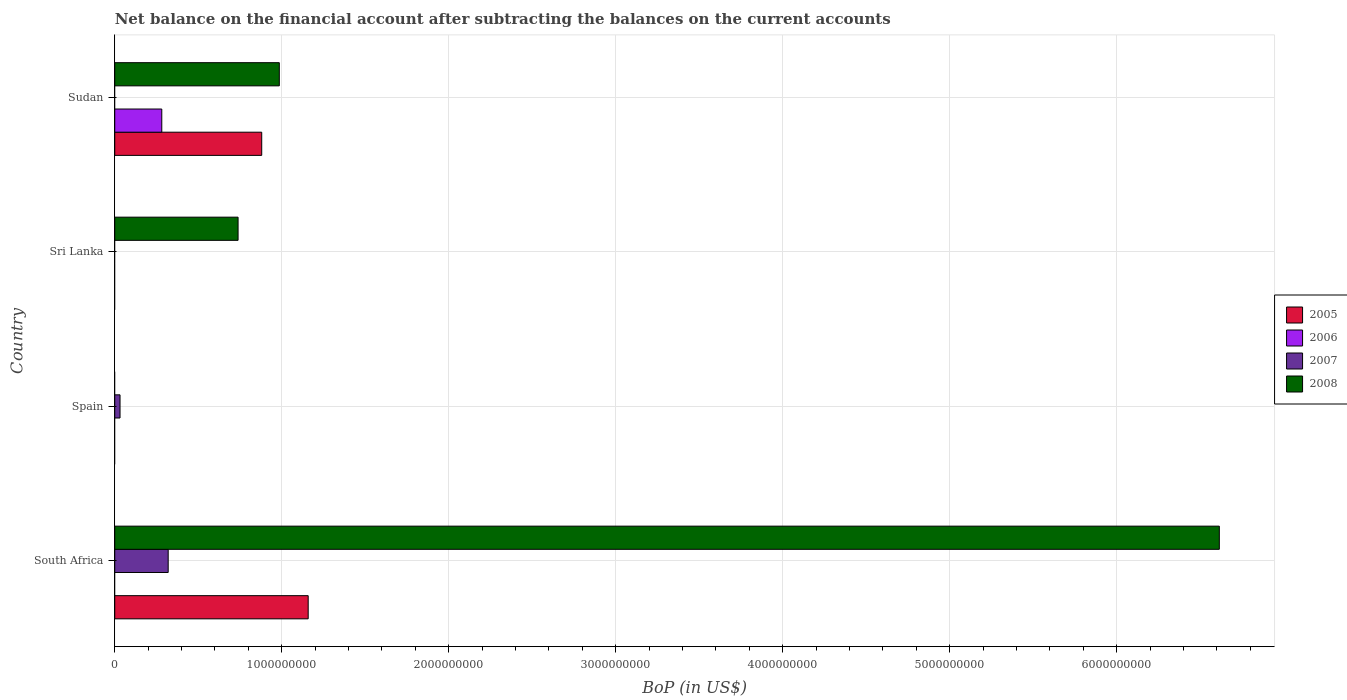Are the number of bars on each tick of the Y-axis equal?
Provide a succinct answer. No. How many bars are there on the 3rd tick from the bottom?
Provide a succinct answer. 1. What is the label of the 1st group of bars from the top?
Your answer should be compact. Sudan. What is the Balance of Payments in 2008 in Sudan?
Keep it short and to the point. 9.86e+08. Across all countries, what is the maximum Balance of Payments in 2006?
Ensure brevity in your answer.  2.82e+08. Across all countries, what is the minimum Balance of Payments in 2008?
Provide a short and direct response. 0. In which country was the Balance of Payments in 2008 maximum?
Provide a succinct answer. South Africa. What is the total Balance of Payments in 2007 in the graph?
Give a very brief answer. 3.52e+08. What is the difference between the Balance of Payments in 2008 in South Africa and that in Sri Lanka?
Make the answer very short. 5.88e+09. What is the difference between the Balance of Payments in 2005 in Sudan and the Balance of Payments in 2008 in South Africa?
Your response must be concise. -5.74e+09. What is the average Balance of Payments in 2007 per country?
Provide a short and direct response. 8.79e+07. What is the difference between the Balance of Payments in 2005 and Balance of Payments in 2008 in Sudan?
Ensure brevity in your answer.  -1.05e+08. In how many countries, is the Balance of Payments in 2005 greater than 3000000000 US$?
Your answer should be very brief. 0. What is the ratio of the Balance of Payments in 2008 in Sri Lanka to that in Sudan?
Offer a terse response. 0.75. What is the difference between the highest and the second highest Balance of Payments in 2008?
Provide a short and direct response. 5.63e+09. What is the difference between the highest and the lowest Balance of Payments in 2008?
Make the answer very short. 6.62e+09. Is it the case that in every country, the sum of the Balance of Payments in 2007 and Balance of Payments in 2006 is greater than the sum of Balance of Payments in 2008 and Balance of Payments in 2005?
Provide a short and direct response. No. Is it the case that in every country, the sum of the Balance of Payments in 2005 and Balance of Payments in 2008 is greater than the Balance of Payments in 2006?
Make the answer very short. No. How many bars are there?
Your response must be concise. 8. Are all the bars in the graph horizontal?
Give a very brief answer. Yes. Are the values on the major ticks of X-axis written in scientific E-notation?
Make the answer very short. No. Does the graph contain any zero values?
Your answer should be compact. Yes. Does the graph contain grids?
Ensure brevity in your answer.  Yes. Where does the legend appear in the graph?
Your answer should be very brief. Center right. How many legend labels are there?
Provide a short and direct response. 4. What is the title of the graph?
Provide a succinct answer. Net balance on the financial account after subtracting the balances on the current accounts. What is the label or title of the X-axis?
Your answer should be very brief. BoP (in US$). What is the BoP (in US$) in 2005 in South Africa?
Your response must be concise. 1.16e+09. What is the BoP (in US$) in 2006 in South Africa?
Provide a short and direct response. 0. What is the BoP (in US$) of 2007 in South Africa?
Offer a terse response. 3.20e+08. What is the BoP (in US$) in 2008 in South Africa?
Provide a short and direct response. 6.62e+09. What is the BoP (in US$) of 2007 in Spain?
Offer a terse response. 3.16e+07. What is the BoP (in US$) of 2008 in Spain?
Ensure brevity in your answer.  0. What is the BoP (in US$) of 2008 in Sri Lanka?
Offer a very short reply. 7.39e+08. What is the BoP (in US$) of 2005 in Sudan?
Ensure brevity in your answer.  8.80e+08. What is the BoP (in US$) of 2006 in Sudan?
Provide a succinct answer. 2.82e+08. What is the BoP (in US$) in 2007 in Sudan?
Provide a succinct answer. 0. What is the BoP (in US$) in 2008 in Sudan?
Ensure brevity in your answer.  9.86e+08. Across all countries, what is the maximum BoP (in US$) in 2005?
Give a very brief answer. 1.16e+09. Across all countries, what is the maximum BoP (in US$) in 2006?
Give a very brief answer. 2.82e+08. Across all countries, what is the maximum BoP (in US$) of 2007?
Offer a very short reply. 3.20e+08. Across all countries, what is the maximum BoP (in US$) in 2008?
Offer a terse response. 6.62e+09. What is the total BoP (in US$) of 2005 in the graph?
Provide a short and direct response. 2.04e+09. What is the total BoP (in US$) of 2006 in the graph?
Keep it short and to the point. 2.82e+08. What is the total BoP (in US$) in 2007 in the graph?
Provide a succinct answer. 3.52e+08. What is the total BoP (in US$) of 2008 in the graph?
Your response must be concise. 8.34e+09. What is the difference between the BoP (in US$) of 2007 in South Africa and that in Spain?
Provide a succinct answer. 2.88e+08. What is the difference between the BoP (in US$) in 2008 in South Africa and that in Sri Lanka?
Offer a very short reply. 5.88e+09. What is the difference between the BoP (in US$) in 2005 in South Africa and that in Sudan?
Provide a succinct answer. 2.78e+08. What is the difference between the BoP (in US$) in 2008 in South Africa and that in Sudan?
Your answer should be very brief. 5.63e+09. What is the difference between the BoP (in US$) of 2008 in Sri Lanka and that in Sudan?
Ensure brevity in your answer.  -2.47e+08. What is the difference between the BoP (in US$) in 2005 in South Africa and the BoP (in US$) in 2007 in Spain?
Offer a very short reply. 1.13e+09. What is the difference between the BoP (in US$) in 2005 in South Africa and the BoP (in US$) in 2008 in Sri Lanka?
Provide a short and direct response. 4.20e+08. What is the difference between the BoP (in US$) in 2007 in South Africa and the BoP (in US$) in 2008 in Sri Lanka?
Ensure brevity in your answer.  -4.19e+08. What is the difference between the BoP (in US$) in 2005 in South Africa and the BoP (in US$) in 2006 in Sudan?
Provide a succinct answer. 8.77e+08. What is the difference between the BoP (in US$) of 2005 in South Africa and the BoP (in US$) of 2008 in Sudan?
Ensure brevity in your answer.  1.73e+08. What is the difference between the BoP (in US$) in 2007 in South Africa and the BoP (in US$) in 2008 in Sudan?
Keep it short and to the point. -6.66e+08. What is the difference between the BoP (in US$) of 2007 in Spain and the BoP (in US$) of 2008 in Sri Lanka?
Provide a short and direct response. -7.07e+08. What is the difference between the BoP (in US$) in 2007 in Spain and the BoP (in US$) in 2008 in Sudan?
Offer a terse response. -9.54e+08. What is the average BoP (in US$) in 2005 per country?
Give a very brief answer. 5.10e+08. What is the average BoP (in US$) of 2006 per country?
Provide a succinct answer. 7.04e+07. What is the average BoP (in US$) of 2007 per country?
Offer a terse response. 8.79e+07. What is the average BoP (in US$) of 2008 per country?
Keep it short and to the point. 2.08e+09. What is the difference between the BoP (in US$) of 2005 and BoP (in US$) of 2007 in South Africa?
Provide a short and direct response. 8.39e+08. What is the difference between the BoP (in US$) in 2005 and BoP (in US$) in 2008 in South Africa?
Provide a succinct answer. -5.46e+09. What is the difference between the BoP (in US$) of 2007 and BoP (in US$) of 2008 in South Africa?
Provide a succinct answer. -6.30e+09. What is the difference between the BoP (in US$) in 2005 and BoP (in US$) in 2006 in Sudan?
Your response must be concise. 5.98e+08. What is the difference between the BoP (in US$) in 2005 and BoP (in US$) in 2008 in Sudan?
Your answer should be very brief. -1.05e+08. What is the difference between the BoP (in US$) in 2006 and BoP (in US$) in 2008 in Sudan?
Make the answer very short. -7.04e+08. What is the ratio of the BoP (in US$) in 2007 in South Africa to that in Spain?
Your answer should be compact. 10.11. What is the ratio of the BoP (in US$) in 2008 in South Africa to that in Sri Lanka?
Give a very brief answer. 8.96. What is the ratio of the BoP (in US$) in 2005 in South Africa to that in Sudan?
Offer a very short reply. 1.32. What is the ratio of the BoP (in US$) of 2008 in South Africa to that in Sudan?
Provide a short and direct response. 6.71. What is the ratio of the BoP (in US$) in 2008 in Sri Lanka to that in Sudan?
Keep it short and to the point. 0.75. What is the difference between the highest and the second highest BoP (in US$) in 2008?
Your answer should be compact. 5.63e+09. What is the difference between the highest and the lowest BoP (in US$) of 2005?
Provide a short and direct response. 1.16e+09. What is the difference between the highest and the lowest BoP (in US$) in 2006?
Keep it short and to the point. 2.82e+08. What is the difference between the highest and the lowest BoP (in US$) of 2007?
Offer a very short reply. 3.20e+08. What is the difference between the highest and the lowest BoP (in US$) in 2008?
Your answer should be compact. 6.62e+09. 